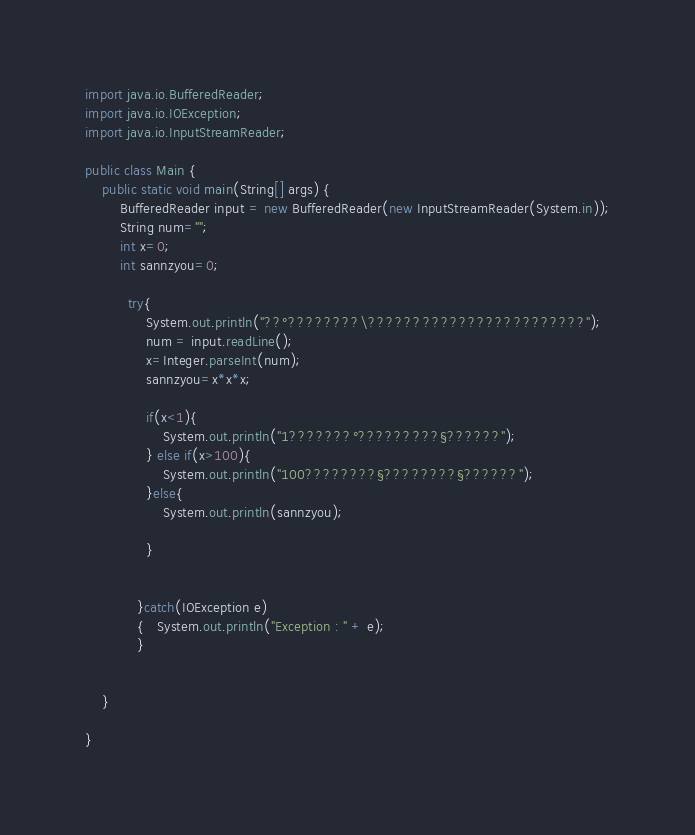Convert code to text. <code><loc_0><loc_0><loc_500><loc_500><_Java_>import java.io.BufferedReader;
import java.io.IOException;
import java.io.InputStreamReader;

public class Main {
	public static void main(String[] args) {
		BufferedReader input = new BufferedReader(new InputStreamReader(System.in));
		String num="";
		int x=0;
		int sannzyou=0;

		  try{
			  System.out.println("??°????????\????????????????????????");
			  num = input.readLine();
			  x=Integer.parseInt(num);
			  sannzyou=x*x*x;

			  if(x<1){
				  System.out.println("1???????°?????????§??????");
			  } else if(x>100){
				  System.out.println("100????????§????????§??????");
			  }else{
                  System.out.println(sannzyou);

			  }


		    }catch(IOException e)
		    {   System.out.println("Exception : " + e);
		    }


	}

}</code> 